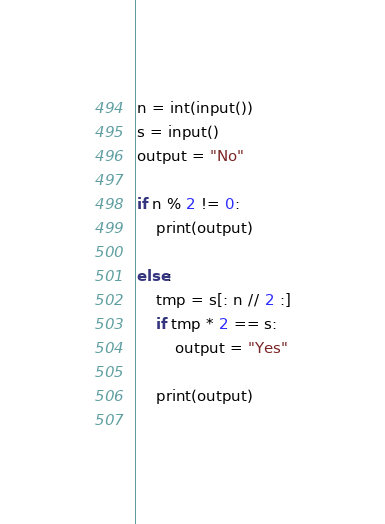<code> <loc_0><loc_0><loc_500><loc_500><_Python_>n = int(input())
s = input()
output = "No"

if n % 2 != 0:
    print(output)

else:
    tmp = s[: n // 2 :]
    if tmp * 2 == s:
        output = "Yes"

    print(output)
    </code> 